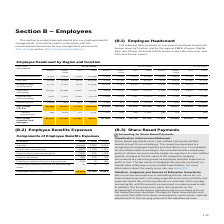According to Sap Ag's financial document, What is the amount of employee benefits expenses in 2019? According to the financial document, 14,870 (in millions). The relevant text states: "Employee benefits expenses 14,870 11,595 11,643..." Also, In which years are the employee benefits expenses calculated? The document contains multiple relevant values: 2019, 2018, 2017. From the document: "€ millions 2019 2018 2017 € millions 2019 2018 2017 € millions 2019 2018 2017..." Also, What are the components considered under employee benefit expenses in the table? The document contains multiple relevant values: Salaries, Social security expenses, Share-based payment expenses, Pension expenses, Employee-related restructuring expenses, Termination benefits outside of restructuring plans. From the document: "Employee-related restructuring expenses 1,111 19 180 Termination benefits outside of restructuring plans Pension expenses 369 330 312 Social security ..." Additionally, In which year were the Termination benefits outside of restructuring plans the largest? According to the financial document, 2017. The relevant text states: "€ millions 2019 2018 2017..." Also, can you calculate: What was the change in Pension expenses in 2019 from 2018? Based on the calculation: 369-330, the result is 39 (in millions). This is based on the information: "Pension expenses 369 330 312 Pension expenses 369 330 312..." The key data points involved are: 330, 369. Also, can you calculate: What was the percentage change in Pension expenses in 2019 from 2018? To answer this question, I need to perform calculations using the financial data. The calculation is: (369-330)/330, which equals 11.82 (percentage). This is based on the information: "Pension expenses 369 330 312 Pension expenses 369 330 312..." The key data points involved are: 330, 369. 